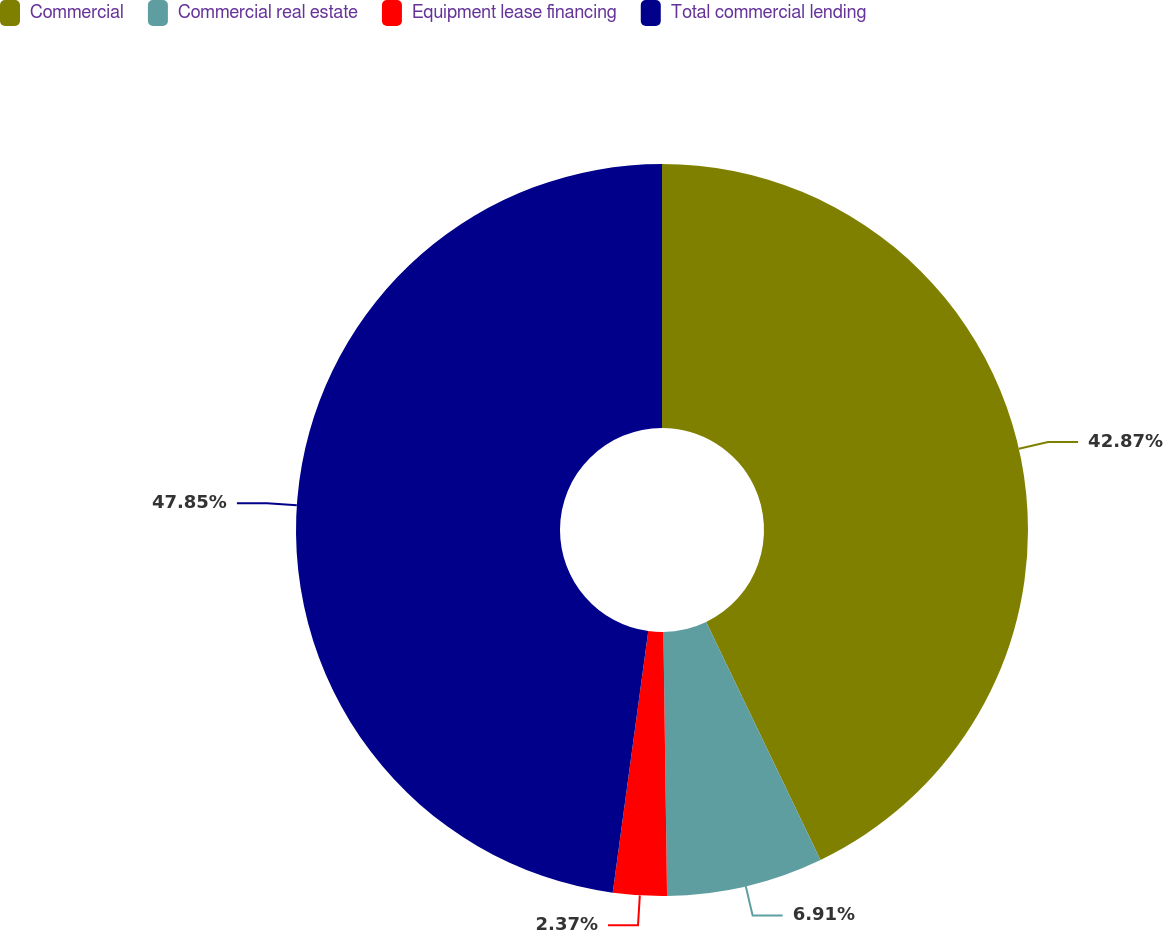<chart> <loc_0><loc_0><loc_500><loc_500><pie_chart><fcel>Commercial<fcel>Commercial real estate<fcel>Equipment lease financing<fcel>Total commercial lending<nl><fcel>42.87%<fcel>6.91%<fcel>2.37%<fcel>47.85%<nl></chart> 